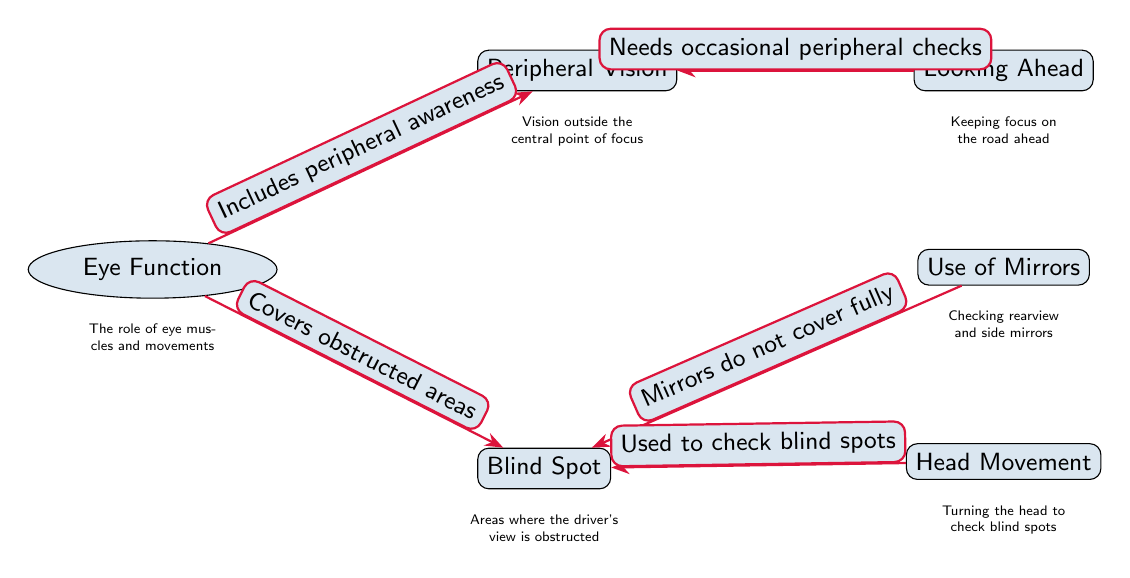What is the title of the main node in the diagram? The main node in the diagram is labeled "Eye Function," which indicates the central topic being discussed regarding eye movement and its role while driving.
Answer: Eye Function How many nodes are in the diagram? There are a total of six nodes in the diagram: Eye Function, Blind Spot, Peripheral Vision, Looking Ahead, Use of Mirrors, and Head Movement.
Answer: 6 What does the node "Blind Spot" refer to? The node "Blind Spot" describes areas where the driver's view is obstructed, indicating critical zones that may not be visible while driving.
Answer: Areas where the driver's view is obstructed What label connects "Looking Ahead" and "Peripheral Vision"? The label connecting "Looking Ahead" and "Peripheral Vision" is "Needs occasional peripheral checks," suggesting the importance of checking side areas even when focused ahead.
Answer: Needs occasional peripheral checks Which node is associated with "Mirrors do not cover fully"? The label "Mirrors do not cover fully" is connected to the "Blind Spot" node, highlighting that mirrors are insufficient to see all areas, necessitating additional checks.
Answer: Blind Spot What is implied by the edge connecting "Head Movement" and "Blind Spot"? The edge implies that head movement is used to check blind spots, suggesting that physically turning one's head is necessary to improve visibility in obscured areas.
Answer: Used to check blind spots Which concept includes "peripheral awareness"? The concept that includes "peripheral awareness" is "Peripheral Vision," indicating that this aspect of vision allows the driver to be aware of their surroundings outside of direct focus.
Answer: Peripheral Vision What is the relationship between "Eye Function" and "Peripheral Vision"? The relationship is captured by the edge labeled "Includes peripheral awareness," indicating that the eye function encompasses the ability to perceive peripheral aspects while driving.
Answer: Includes peripheral awareness What is the significance of the "Use of Mirrors" in relation to "Blind Spot"? The significance is that the label "Mirrors do not cover fully" emphasizes the limitation of mirrors in addressing blind spots, hence the need for additional visual checks.
Answer: Mirrors do not cover fully 